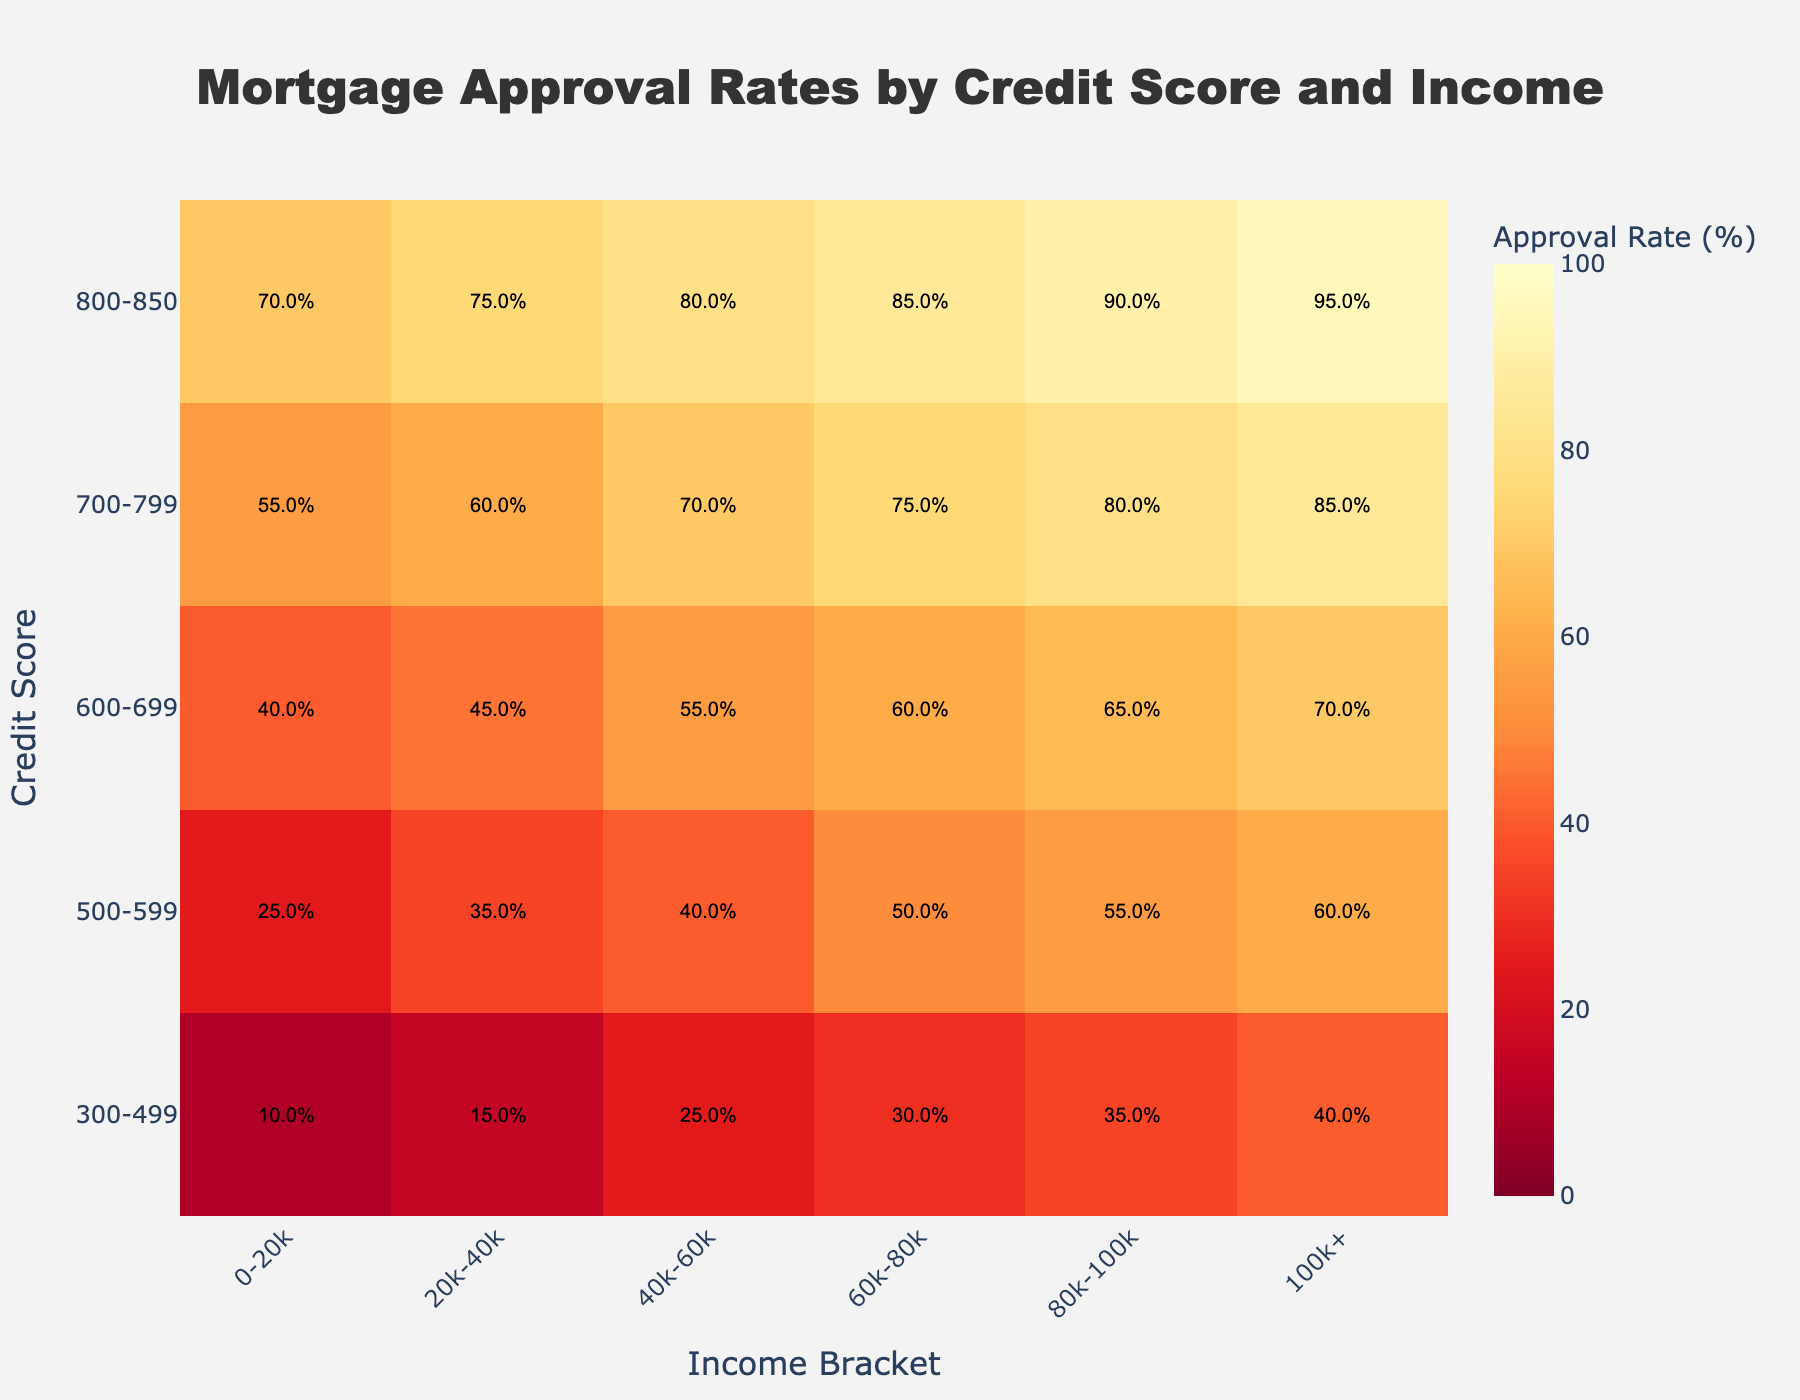What's the title of the heatmap? The title is located at the top of the heatmap and reads: "Mortgage Approval Rates by Credit Score and Income".
Answer: Mortgage Approval Rates by Credit Score and Income What's the approval rate for the 700-799 credit score and 60k-80k income bracket? Locate the row representing the 700-799 credit score and the column representing the 60k-80k income bracket. The approval rate at this intersection is 75%.
Answer: 75% What trend can be observed as the income bracket increases for a 300-499 credit score? Observing the values in the 300-499 row, the approval rate increases as the income bracket increases, starting at 10% for the 0-20k income bracket and reaching 40% for the 100k+ income bracket.
Answer: Approval rate increases How does the approval rate for the 500-599 credit score bracket compare between the 20k-40k income and the 100k+ income? Look at the values in the 500-599 row for both the 20k-40k and 100k+ columns. The approval rates are 35% and 60% respectively.
Answer: 60% is higher than 35% Which credit score bracket shows the highest approval rate for the 0-20k income bracket? Compare the approval rates for the 0-20k income bracket across all credit score rows. The highest rate, 70%, is in the 800-850 credit score bracket.
Answer: 800-850 What's the average mortgage approval rate for the 700-799 credit score bracket across all income brackets? Add the approval rates for the 700-799 credit score across all income brackets: 55%, 60%, 70%, 75%, 80%, 85%. The sum is 425%, and there are 6 data points, so the average is 425/6 = 70.83%.
Answer: 70.83% What pattern do you notice in the approval rates for the 800-850 credit score bracket? Examine the values in the 800-850 row. The approval rates increase progressively from 70% for the 0-20k income bracket to 95% for the 100k+ income bracket.
Answer: Approval rates increase progressively Is there a larger increment in approval rate moving from a 600-699 credit score to a 700-799 credit score, or from a 700-799 credit score to an 800-850 credit score for the 60k-80k income bracket? For the 60k-80k income bracket, calculate the differences: 700-799 (75%) - 600-699 (60%) = 15%, and 800-850 (85%) - 700-799 (75%) = 10%. The increment from 600-699 to 700-799 is larger.
Answer: From 600-699 to 700-799 What is the overall range of mortgage approval rates depicted in the heatmap? Identify the minimum and maximum approval rates in the data. The smallest value is 10%, and the largest is 95%. The overall range is 95% - 10% = 85%.
Answer: 85% 